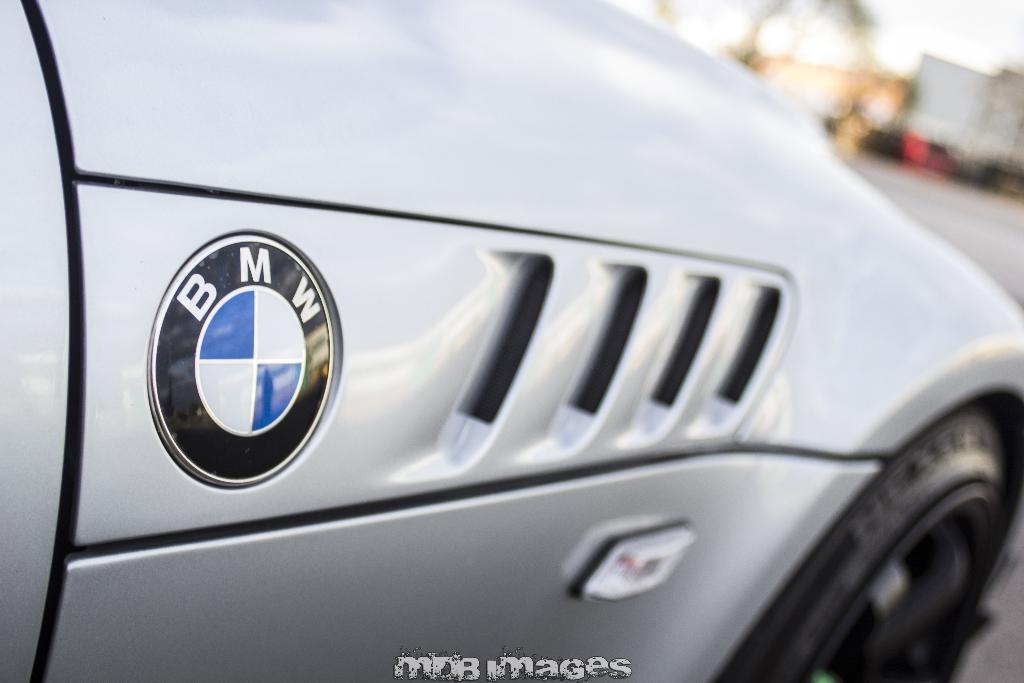What type of vehicle is in the picture? There is a car in the picture. What color is the car? The car is gray in color. What brand is the car? The car has a BMW symbol on it, indicating that it is a BMW. What part of the car can be seen in the image? There is a black tire visible in the image. Can you see your aunt petting a kitten in the image? There is no mention of an aunt or a kitten in the image; it features a gray BMW car with a visible black tire. 